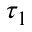Convert formula to latex. <formula><loc_0><loc_0><loc_500><loc_500>\tau _ { 1 }</formula> 